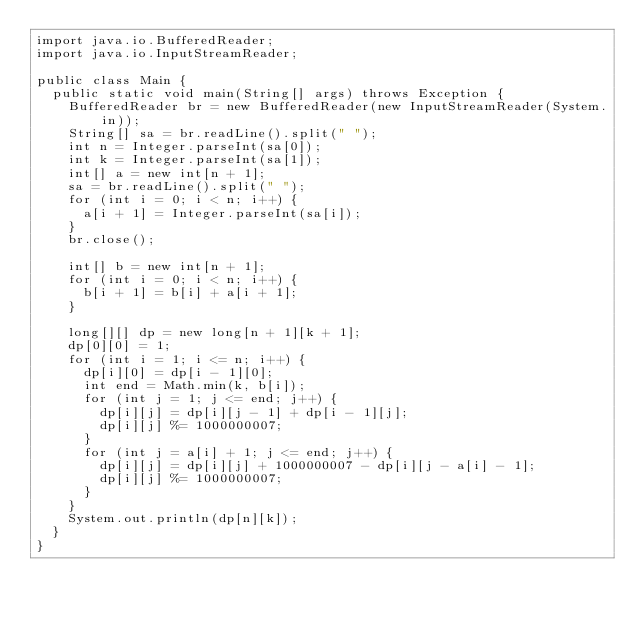Convert code to text. <code><loc_0><loc_0><loc_500><loc_500><_Java_>import java.io.BufferedReader;
import java.io.InputStreamReader;

public class Main {
	public static void main(String[] args) throws Exception {
		BufferedReader br = new BufferedReader(new InputStreamReader(System.in));
		String[] sa = br.readLine().split(" ");
		int n = Integer.parseInt(sa[0]);
		int k = Integer.parseInt(sa[1]);
		int[] a = new int[n + 1];
		sa = br.readLine().split(" ");
		for (int i = 0; i < n; i++) {
			a[i + 1] = Integer.parseInt(sa[i]);
		}
		br.close();

		int[] b = new int[n + 1];
		for (int i = 0; i < n; i++) {
			b[i + 1] = b[i] + a[i + 1];
		}
		
		long[][] dp = new long[n + 1][k + 1];
		dp[0][0] = 1;
		for (int i = 1; i <= n; i++) {
			dp[i][0] = dp[i - 1][0];
			int end = Math.min(k, b[i]);
			for (int j = 1; j <= end; j++) {
				dp[i][j] = dp[i][j - 1] + dp[i - 1][j];
				dp[i][j] %= 1000000007;
			}
			for (int j = a[i] + 1; j <= end; j++) {
				dp[i][j] = dp[i][j] + 1000000007 - dp[i][j - a[i] - 1];
				dp[i][j] %= 1000000007;
			}
		}
		System.out.println(dp[n][k]);
	}
}
</code> 